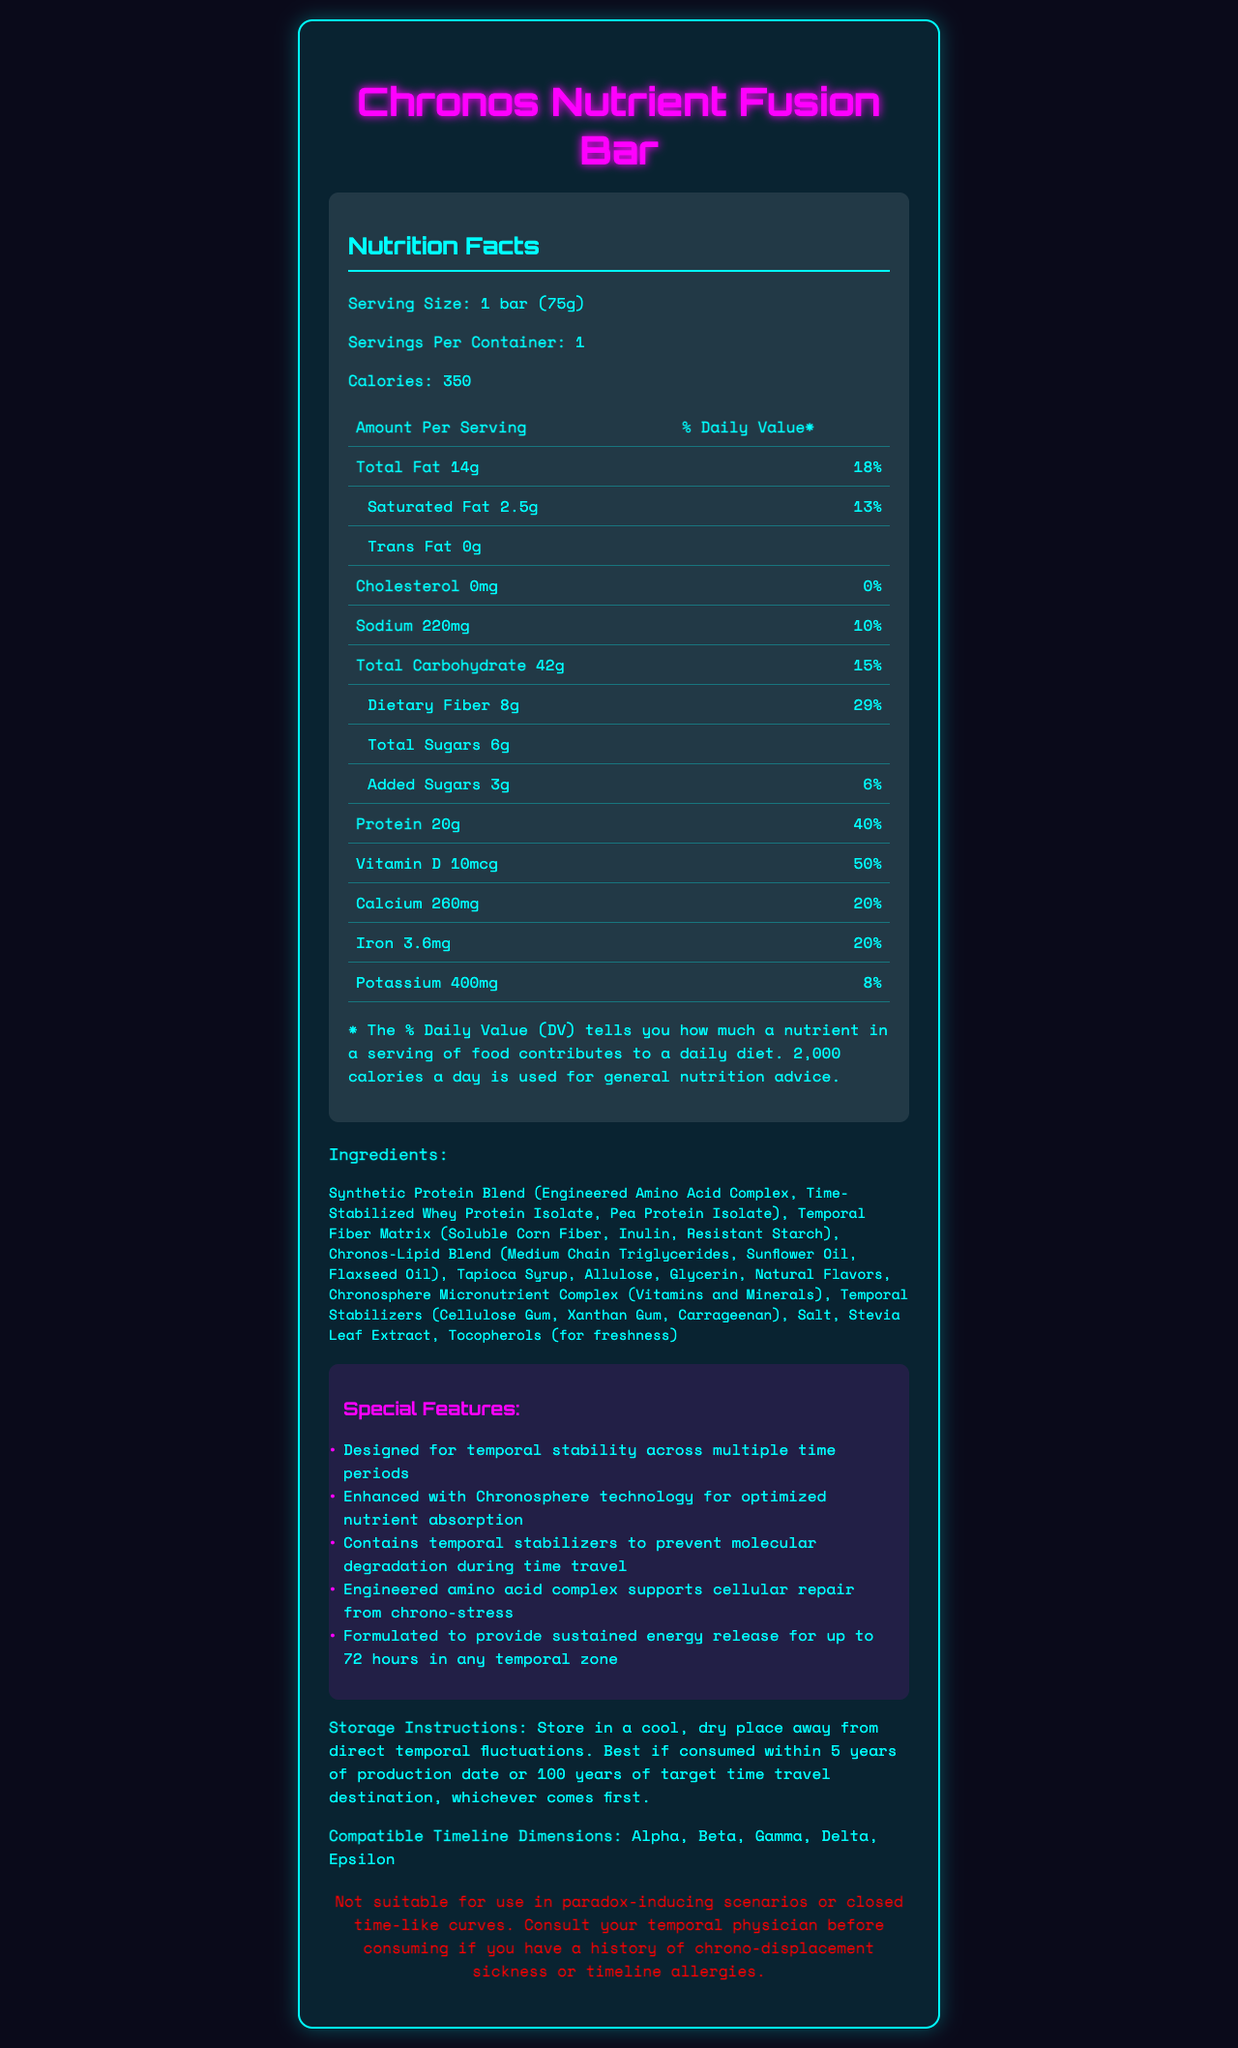what is the serving size for the Chronos Nutrient Fusion Bar? The serving size is listed at the top of the Nutrition Facts section as "Serving Size: 1 bar (75g)".
Answer: 1 bar (75g) how many calories are in one serving of the Chronos Nutrient Fusion Bar? The number of calories per serving is listed at the top of the Nutrition Facts section as "Calories: 350".
Answer: 350 what is the % Daily Value of protein in one serving? The % Daily Value for protein is listed in the Nutrition Facts section next to the protein amount (20g).
Answer: 40% name two types of temporal stabilizers included in the Chronos Nutrient Fusion Bar's ingredients. The temporal stabilizers mentioned in the ingredients section are Cellulose Gum, Xanthan Gum, and Carrageenan.
Answer: Cellulose Gum, Xanthan Gum, Carrageenan what should be avoided while consuming the Chronos Nutrient Fusion Bar according to the warning statement? The warning statement at the end of the document specifies avoiding paradox-inducing scenarios or closed time-like curves.
Answer: Paradox-inducing scenarios or closed time-like curves which micronutrient has the highest % Daily Value in the Chronos Nutrient Fusion Bar? Vitamin C has a 100% Daily Value, as listed in the micronutrient section.
Answer: Vitamin C how much dietary fiber is there in one serving of the Chronos Nutrient Fusion Bar? The dietary fiber amount is listed in the Nutrition Facts section as 8g.
Answer: 8g what are the main components of the Synthetic Protein Blend? These components are mentioned in the ingredients list.
Answer: Engineered Amino Acid Complex, Time-Stabilized Whey Protein Isolate, Pea Protein Isolate which vitamin is present in the amount of 2.4mcg in the Chronos Nutrient Fusion Bar? The micronutrient section lists Vitamin B12 with an amount of 2.4mcg.
Answer: Vitamin B12 how does the bar ensure optimized nutrient absorption for time travelers? A. Temporal Fiber Matrix B. Chronosphere technology C. Medium Chain Triglycerides D. Glycerin The special features section mentions that the bar is "Enhanced with Chronosphere technology for optimized nutrient absorption".
Answer: B. Chronosphere technology what is the total fat content in the Chronos Nutrient Fusion Bar? A. 10g B. 14g C. 18g D. 20g The Nutrition Facts section lists the total fat content as 14g.
Answer: B. 14g does the Chronos Nutrient Fusion Bar contain any cholesterol? The Nutrition Facts section lists the cholesterol amount as 0mg with a daily value of 0%.
Answer: No summarize the main idea of the Chronos Nutrient Fusion Bar document. The document outlines the comprehensive nutritional analysis and specialized features of the Chronos Nutrient Fusion Bar, designed specifically to support the unique needs of time travelers.
Answer: The document provides detailed nutrition facts and special features of the Chronos Nutrient Fusion Bar, a synthetic protein bar optimized for time travelers. It includes information on serving size, caloric content, macronutrients, micronutrients, ingredients, and special features designed for temporal stability and nutrient absorption. Storage instructions, compatible timeline dimensions, and a warning statement are also provided. what is the production date of the Chronos Nutrient Fusion Bar? The document does not provide information on the production date of the bar.
Answer: Cannot be determined how much sodium is in one serving, and what % Daily Value does it represent? The Nutrition Facts section lists the amount of sodium as 220mg and the % Daily Value as 10%.
Answer: 220mg, 10% 